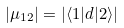Convert formula to latex. <formula><loc_0><loc_0><loc_500><loc_500>| \mu _ { 1 2 } | = | \langle 1 | d | 2 \rangle |</formula> 